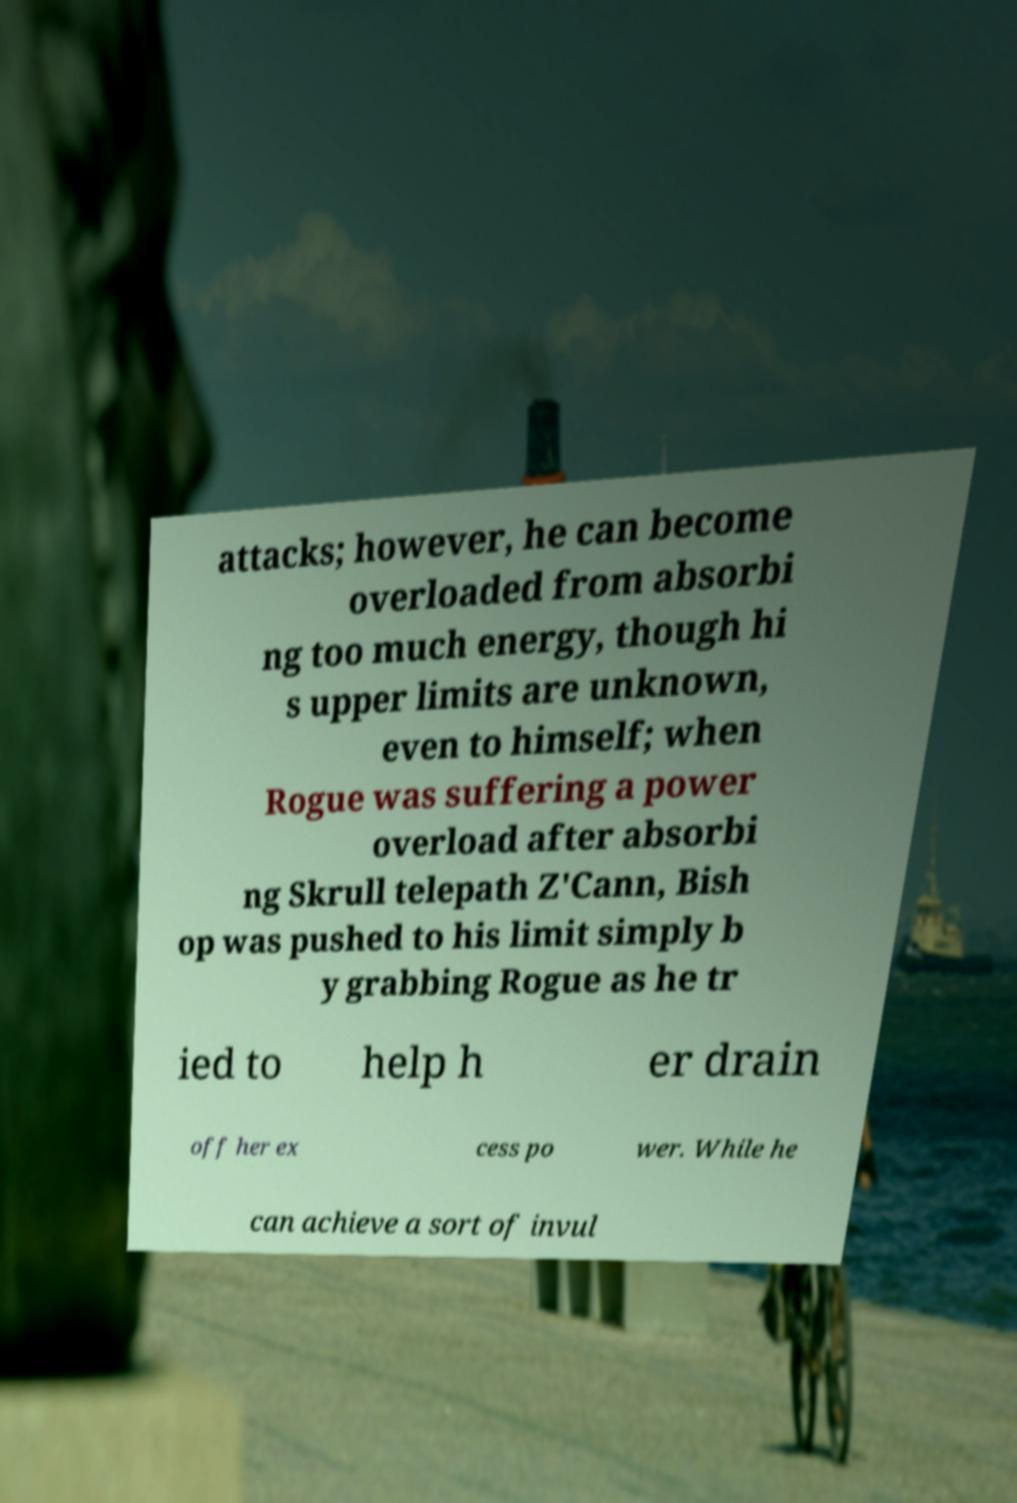Can you read and provide the text displayed in the image?This photo seems to have some interesting text. Can you extract and type it out for me? attacks; however, he can become overloaded from absorbi ng too much energy, though hi s upper limits are unknown, even to himself; when Rogue was suffering a power overload after absorbi ng Skrull telepath Z'Cann, Bish op was pushed to his limit simply b y grabbing Rogue as he tr ied to help h er drain off her ex cess po wer. While he can achieve a sort of invul 